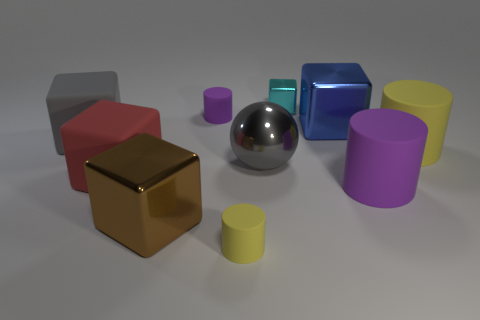Is there a brown block that is to the right of the yellow rubber cylinder that is to the right of the purple rubber thing on the right side of the blue shiny object?
Your answer should be compact. No. What is the material of the large red object that is the same shape as the cyan metallic thing?
Your answer should be compact. Rubber. Are there any other things that are the same material as the tiny purple cylinder?
Give a very brief answer. Yes. How many cylinders are gray rubber objects or large brown objects?
Your answer should be compact. 0. There is a metallic block that is left of the small cyan shiny cube; is it the same size as the ball that is on the left side of the large yellow thing?
Your answer should be very brief. Yes. What is the material of the gray thing in front of the big matte cylinder behind the big gray ball?
Give a very brief answer. Metal. Is the number of large brown objects that are in front of the big brown metal object less than the number of big yellow rubber cylinders?
Provide a short and direct response. Yes. The gray thing that is the same material as the brown block is what shape?
Your response must be concise. Sphere. How many other things are there of the same shape as the big blue shiny thing?
Offer a very short reply. 4. What number of gray objects are matte cubes or large matte cylinders?
Offer a very short reply. 1. 